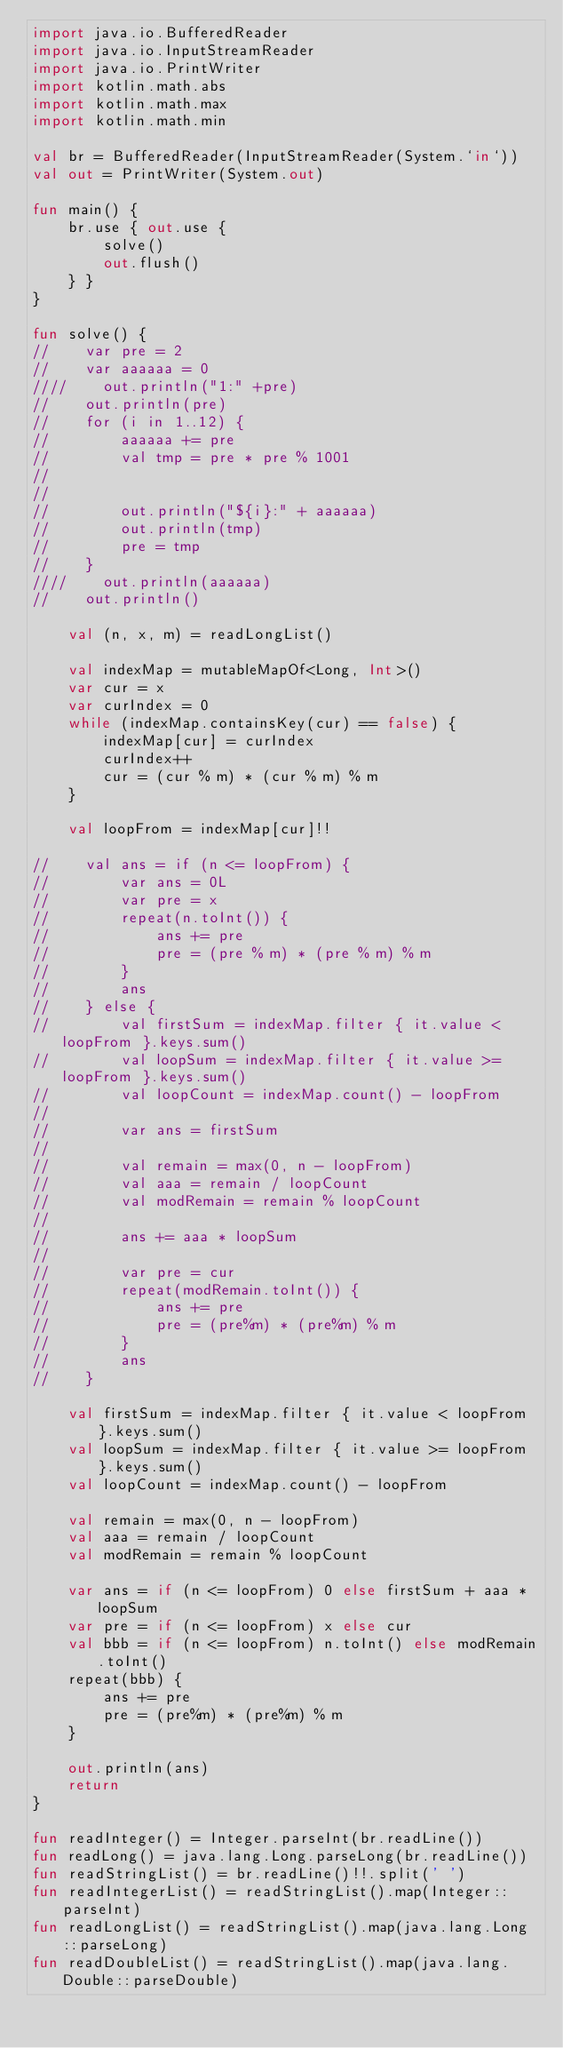<code> <loc_0><loc_0><loc_500><loc_500><_Kotlin_>import java.io.BufferedReader
import java.io.InputStreamReader
import java.io.PrintWriter
import kotlin.math.abs
import kotlin.math.max
import kotlin.math.min

val br = BufferedReader(InputStreamReader(System.`in`))
val out = PrintWriter(System.out)

fun main() {
    br.use { out.use {
        solve()
        out.flush()
    } }
}

fun solve() {
//    var pre = 2
//    var aaaaaa = 0
////    out.println("1:" +pre)
//    out.println(pre)
//    for (i in 1..12) {
//        aaaaaa += pre
//        val tmp = pre * pre % 1001
//
//
//        out.println("${i}:" + aaaaaa)
//        out.println(tmp)
//        pre = tmp
//    }
////    out.println(aaaaaa)
//    out.println()

    val (n, x, m) = readLongList()

    val indexMap = mutableMapOf<Long, Int>()
    var cur = x
    var curIndex = 0
    while (indexMap.containsKey(cur) == false) {
        indexMap[cur] = curIndex
        curIndex++
        cur = (cur % m) * (cur % m) % m
    }

    val loopFrom = indexMap[cur]!!

//    val ans = if (n <= loopFrom) {
//        var ans = 0L
//        var pre = x
//        repeat(n.toInt()) {
//            ans += pre
//            pre = (pre % m) * (pre % m) % m
//        }
//        ans
//    } else {
//        val firstSum = indexMap.filter { it.value < loopFrom }.keys.sum()
//        val loopSum = indexMap.filter { it.value >= loopFrom }.keys.sum()
//        val loopCount = indexMap.count() - loopFrom
//
//        var ans = firstSum
//
//        val remain = max(0, n - loopFrom)
//        val aaa = remain / loopCount
//        val modRemain = remain % loopCount
//
//        ans += aaa * loopSum
//
//        var pre = cur
//        repeat(modRemain.toInt()) {
//            ans += pre
//            pre = (pre%m) * (pre%m) % m
//        }
//        ans
//    }

    val firstSum = indexMap.filter { it.value < loopFrom }.keys.sum()
    val loopSum = indexMap.filter { it.value >= loopFrom }.keys.sum()
    val loopCount = indexMap.count() - loopFrom

    val remain = max(0, n - loopFrom)
    val aaa = remain / loopCount
    val modRemain = remain % loopCount

    var ans = if (n <= loopFrom) 0 else firstSum + aaa * loopSum
    var pre = if (n <= loopFrom) x else cur
    val bbb = if (n <= loopFrom) n.toInt() else modRemain.toInt()
    repeat(bbb) {
        ans += pre
        pre = (pre%m) * (pre%m) % m
    }

    out.println(ans)
    return
}

fun readInteger() = Integer.parseInt(br.readLine())
fun readLong() = java.lang.Long.parseLong(br.readLine())
fun readStringList() = br.readLine()!!.split(' ')
fun readIntegerList() = readStringList().map(Integer::parseInt)
fun readLongList() = readStringList().map(java.lang.Long::parseLong)
fun readDoubleList() = readStringList().map(java.lang.Double::parseDouble)
</code> 